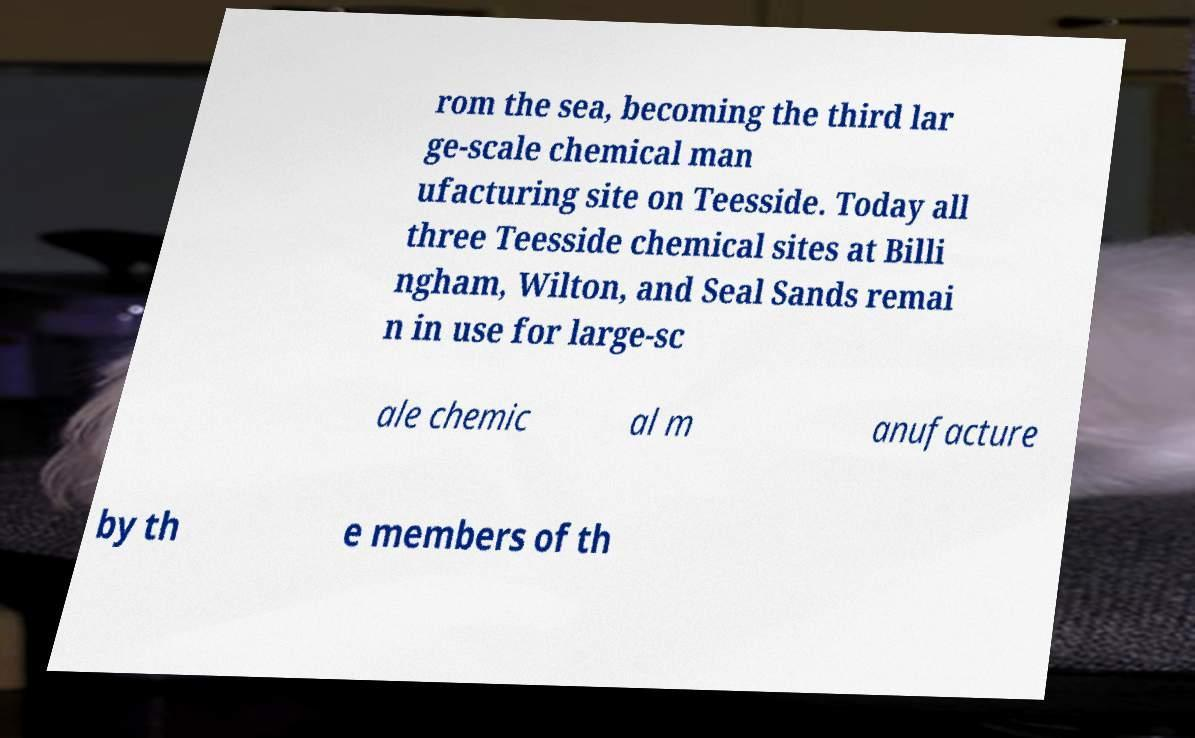Could you extract and type out the text from this image? rom the sea, becoming the third lar ge-scale chemical man ufacturing site on Teesside. Today all three Teesside chemical sites at Billi ngham, Wilton, and Seal Sands remai n in use for large-sc ale chemic al m anufacture by th e members of th 